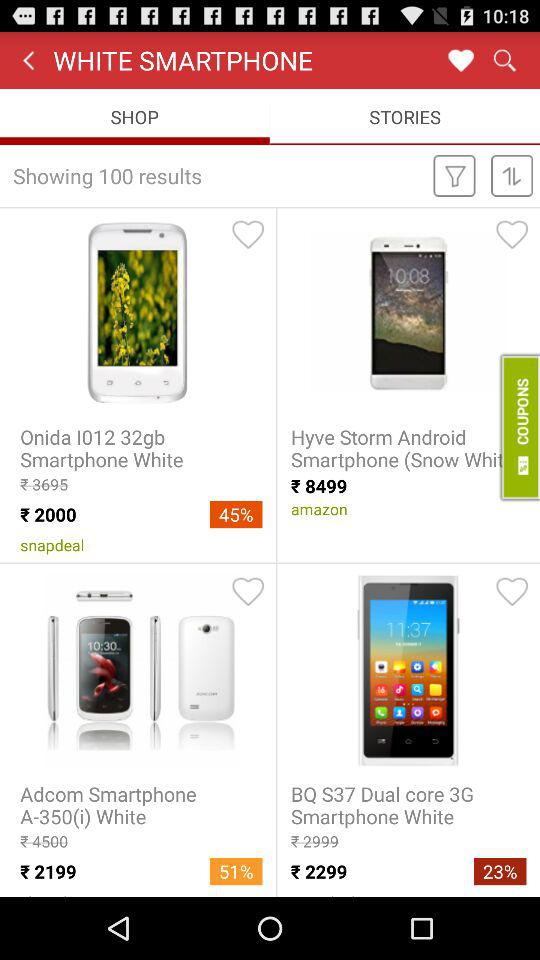How many results are shown? The number of results shown is 100. 